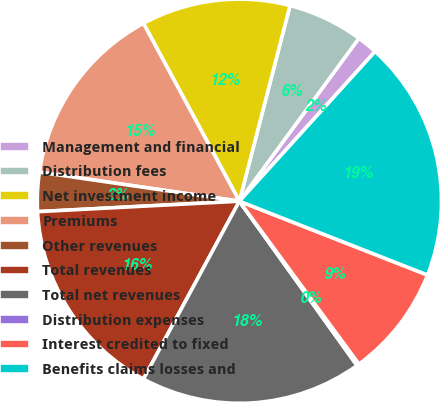Convert chart to OTSL. <chart><loc_0><loc_0><loc_500><loc_500><pie_chart><fcel>Management and financial<fcel>Distribution fees<fcel>Net investment income<fcel>Premiums<fcel>Other revenues<fcel>Total revenues<fcel>Total net revenues<fcel>Distribution expenses<fcel>Interest credited to fixed<fcel>Benefits claims losses and<nl><fcel>1.65%<fcel>6.04%<fcel>11.9%<fcel>14.83%<fcel>3.12%<fcel>16.3%<fcel>17.76%<fcel>0.19%<fcel>8.97%<fcel>19.23%<nl></chart> 